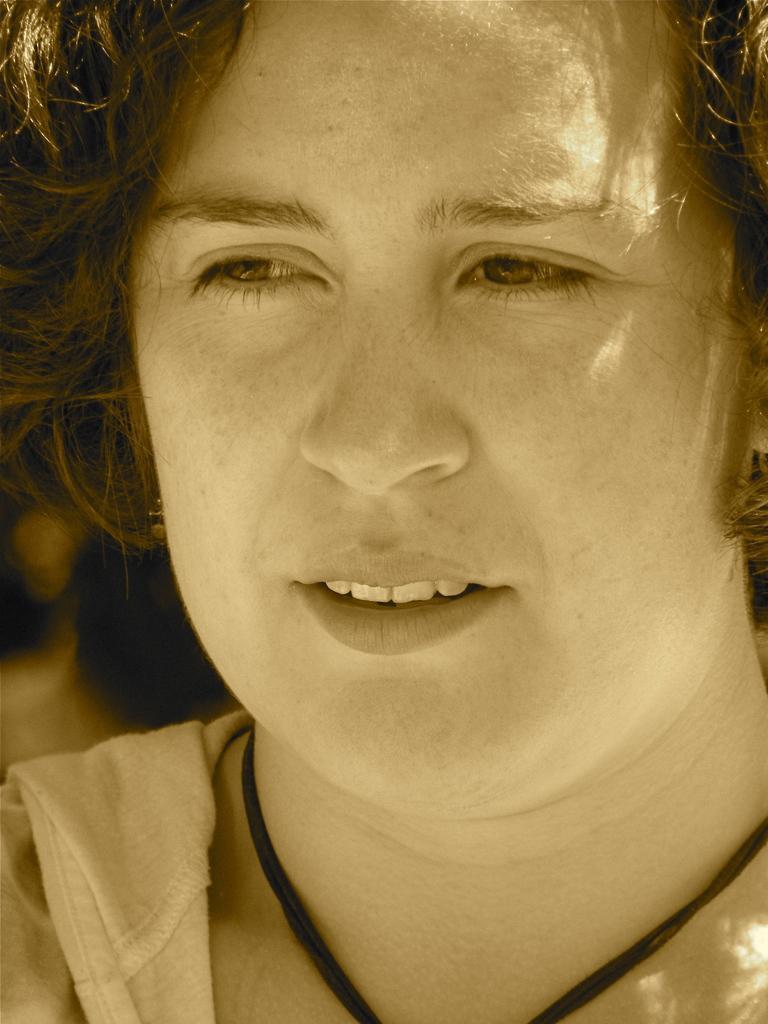Can you describe this image briefly? In this image I can see a person face. 